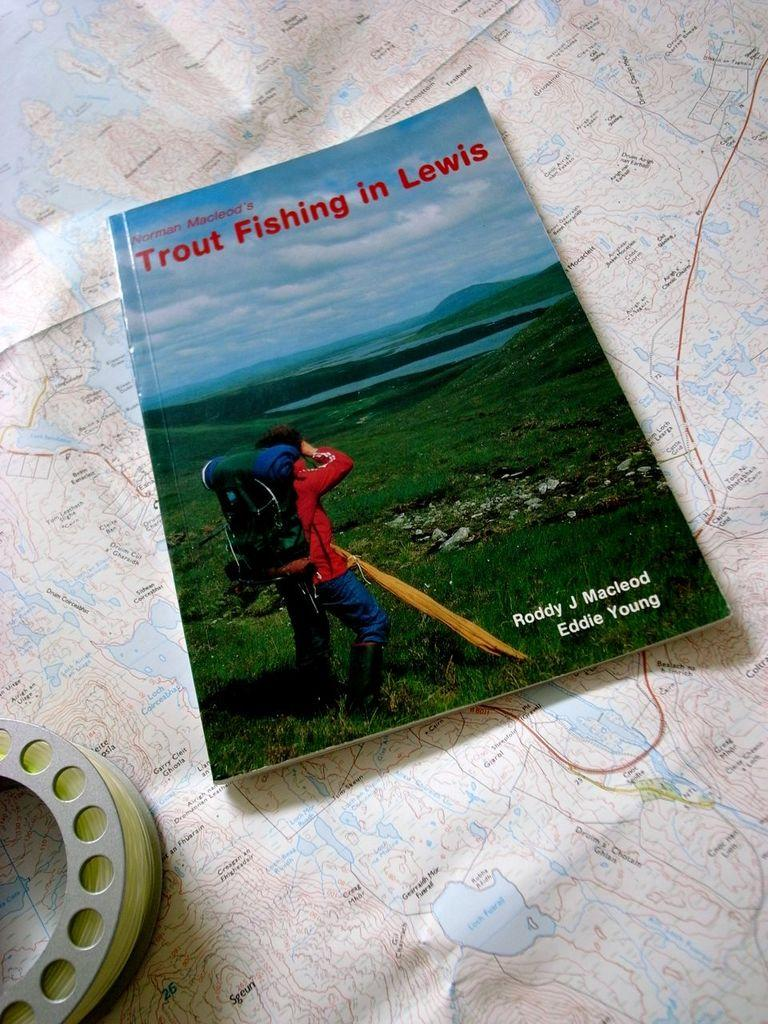<image>
Provide a brief description of the given image. The book Norman Macleod's Trout Fishing in Lewis is laid on a map next to a fly fishing reel. 